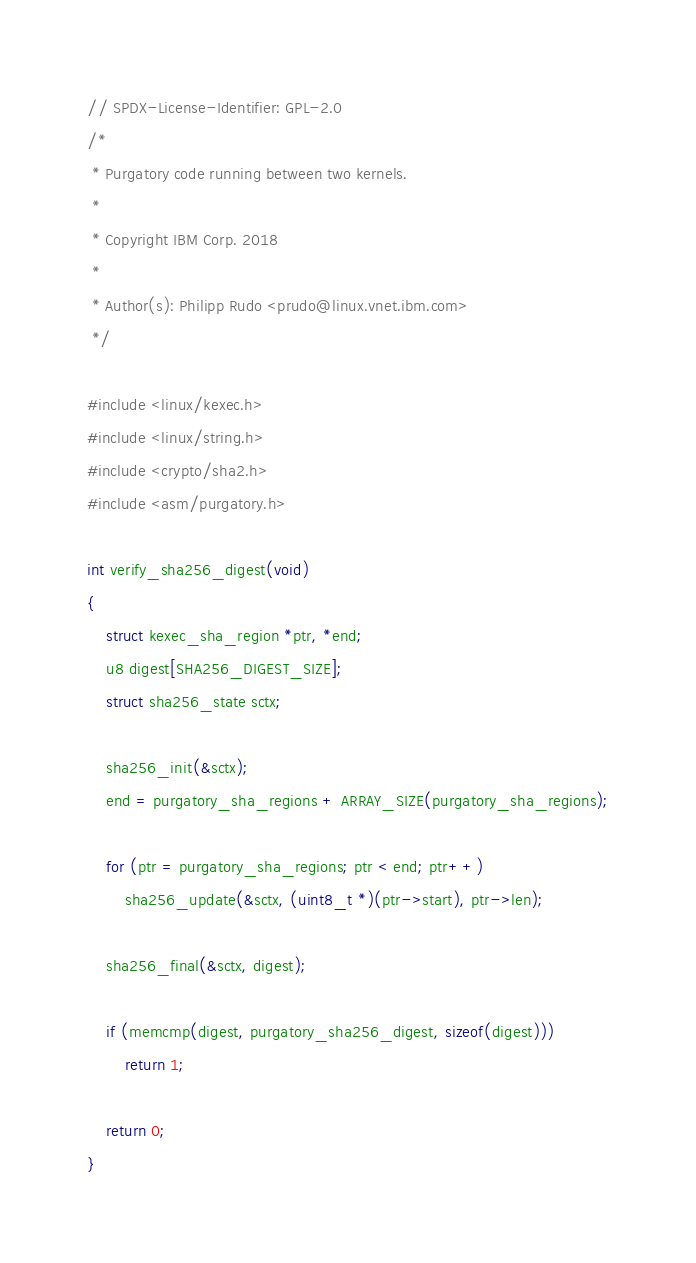<code> <loc_0><loc_0><loc_500><loc_500><_C_>// SPDX-License-Identifier: GPL-2.0
/*
 * Purgatory code running between two kernels.
 *
 * Copyright IBM Corp. 2018
 *
 * Author(s): Philipp Rudo <prudo@linux.vnet.ibm.com>
 */

#include <linux/kexec.h>
#include <linux/string.h>
#include <crypto/sha2.h>
#include <asm/purgatory.h>

int verify_sha256_digest(void)
{
	struct kexec_sha_region *ptr, *end;
	u8 digest[SHA256_DIGEST_SIZE];
	struct sha256_state sctx;

	sha256_init(&sctx);
	end = purgatory_sha_regions + ARRAY_SIZE(purgatory_sha_regions);

	for (ptr = purgatory_sha_regions; ptr < end; ptr++)
		sha256_update(&sctx, (uint8_t *)(ptr->start), ptr->len);

	sha256_final(&sctx, digest);

	if (memcmp(digest, purgatory_sha256_digest, sizeof(digest)))
		return 1;

	return 0;
}
</code> 